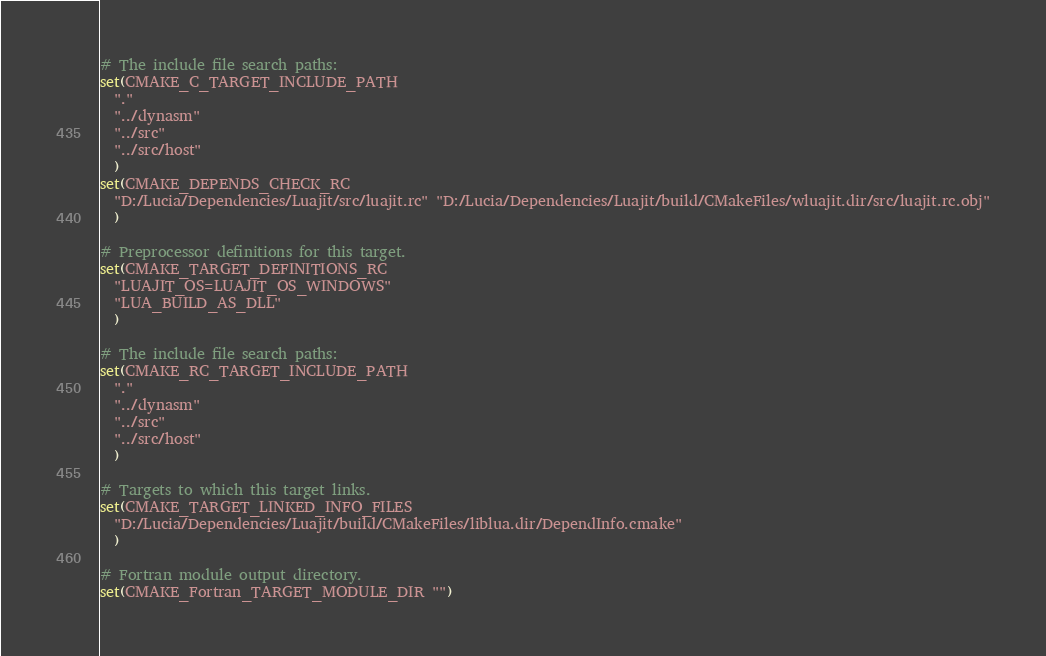Convert code to text. <code><loc_0><loc_0><loc_500><loc_500><_CMake_>
# The include file search paths:
set(CMAKE_C_TARGET_INCLUDE_PATH
  "."
  "../dynasm"
  "../src"
  "../src/host"
  )
set(CMAKE_DEPENDS_CHECK_RC
  "D:/Lucia/Dependencies/Luajit/src/luajit.rc" "D:/Lucia/Dependencies/Luajit/build/CMakeFiles/wluajit.dir/src/luajit.rc.obj"
  )

# Preprocessor definitions for this target.
set(CMAKE_TARGET_DEFINITIONS_RC
  "LUAJIT_OS=LUAJIT_OS_WINDOWS"
  "LUA_BUILD_AS_DLL"
  )

# The include file search paths:
set(CMAKE_RC_TARGET_INCLUDE_PATH
  "."
  "../dynasm"
  "../src"
  "../src/host"
  )

# Targets to which this target links.
set(CMAKE_TARGET_LINKED_INFO_FILES
  "D:/Lucia/Dependencies/Luajit/build/CMakeFiles/liblua.dir/DependInfo.cmake"
  )

# Fortran module output directory.
set(CMAKE_Fortran_TARGET_MODULE_DIR "")
</code> 